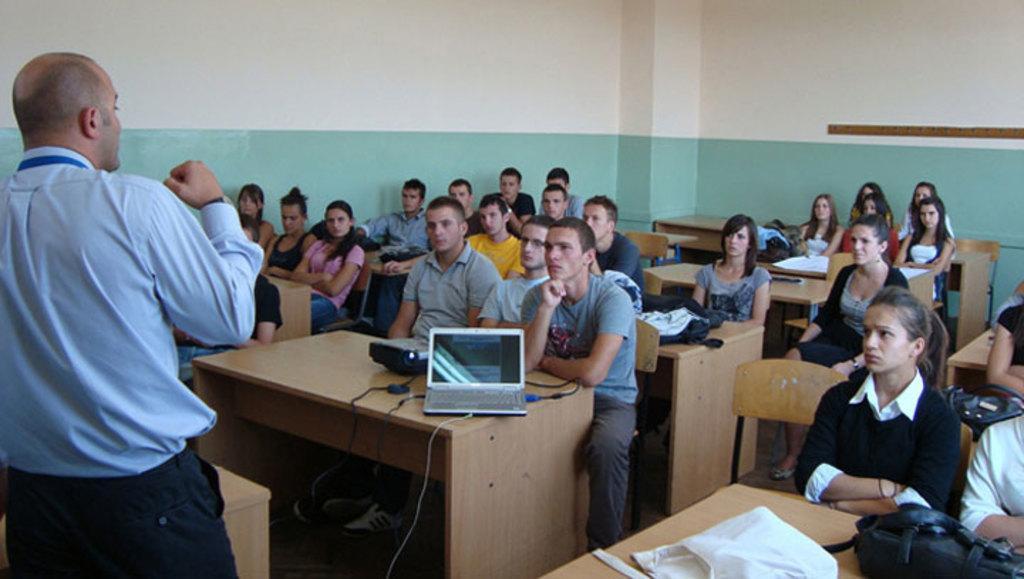Please provide a concise description of this image. This is a wall. Here we can see all the students sitting on chairs in front of a table and on the table we can see bags, laptop and a projector device. We can see one man standing here. 